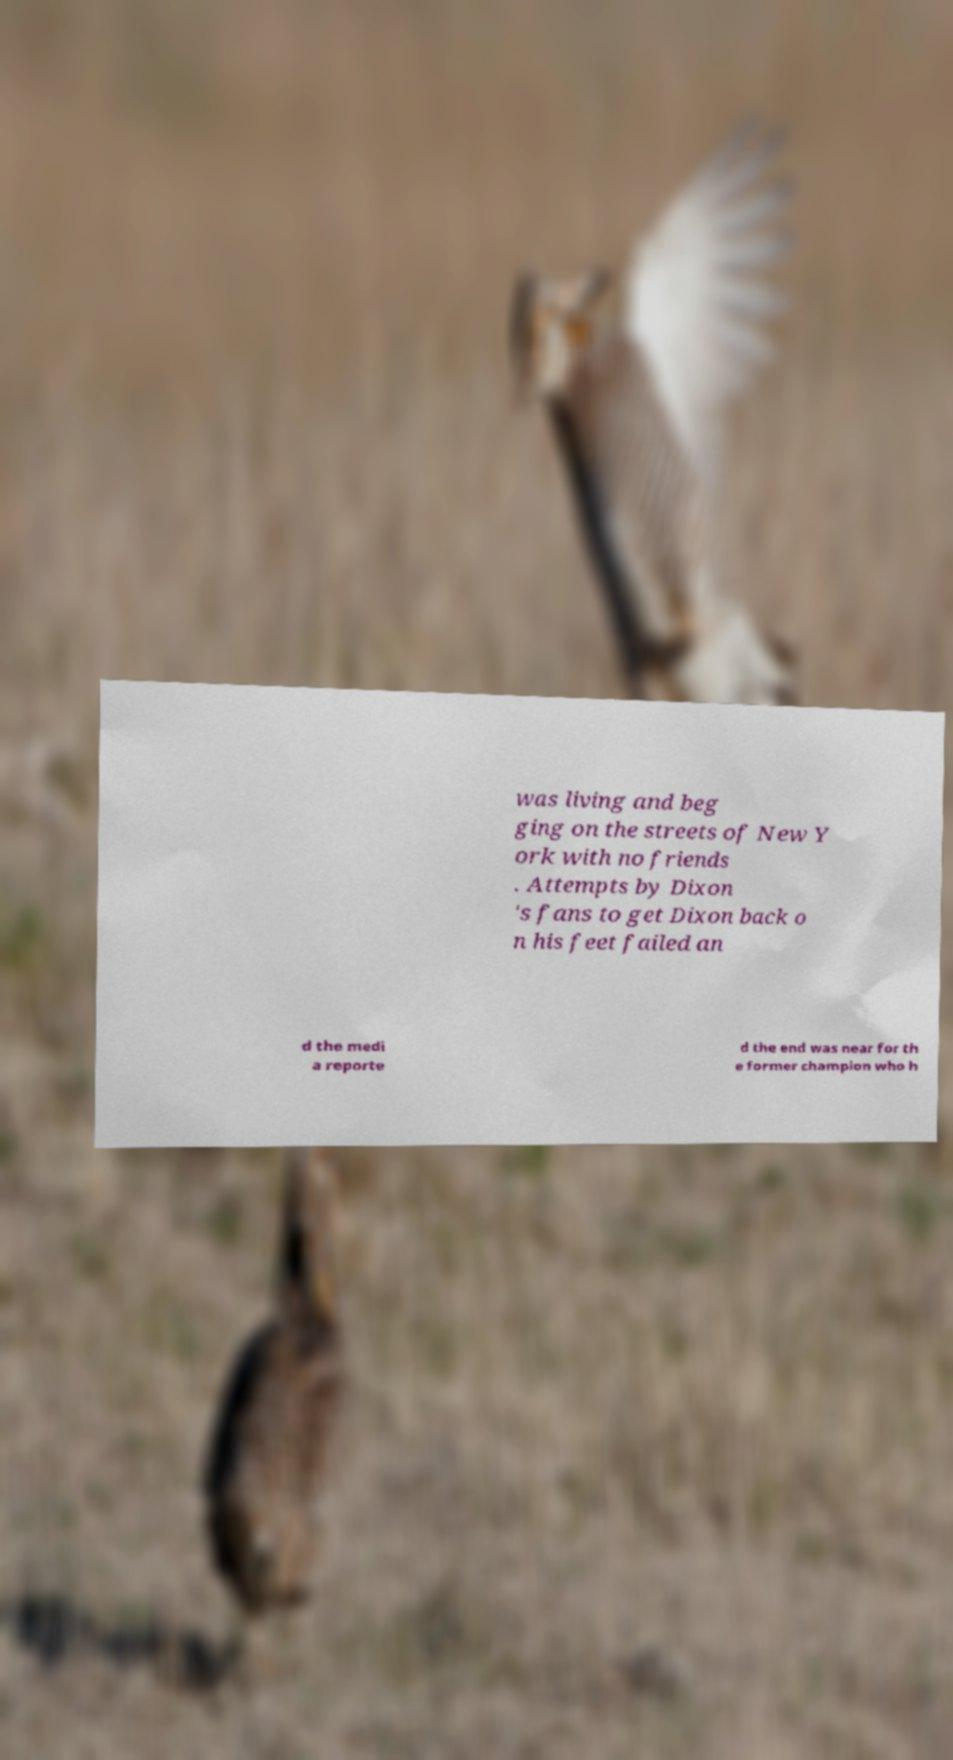Could you assist in decoding the text presented in this image and type it out clearly? was living and beg ging on the streets of New Y ork with no friends . Attempts by Dixon 's fans to get Dixon back o n his feet failed an d the medi a reporte d the end was near for th e former champion who h 